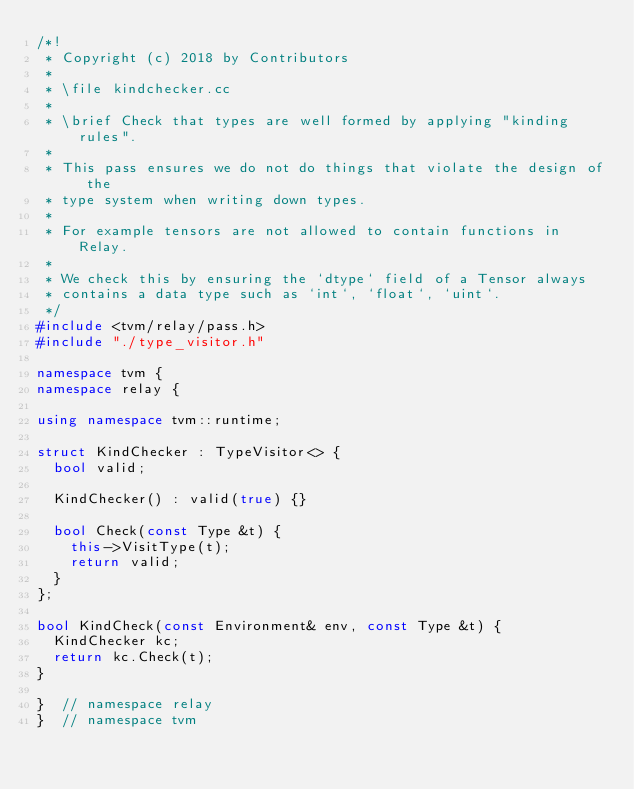Convert code to text. <code><loc_0><loc_0><loc_500><loc_500><_C++_>/*!
 * Copyright (c) 2018 by Contributors
 *
 * \file kindchecker.cc
 *
 * \brief Check that types are well formed by applying "kinding rules".
 *
 * This pass ensures we do not do things that violate the design of the
 * type system when writing down types.
 *
 * For example tensors are not allowed to contain functions in Relay.
 *
 * We check this by ensuring the `dtype` field of a Tensor always
 * contains a data type such as `int`, `float`, `uint`.
 */
#include <tvm/relay/pass.h>
#include "./type_visitor.h"

namespace tvm {
namespace relay {

using namespace tvm::runtime;

struct KindChecker : TypeVisitor<> {
  bool valid;

  KindChecker() : valid(true) {}

  bool Check(const Type &t) {
    this->VisitType(t);
    return valid;
  }
};

bool KindCheck(const Environment& env, const Type &t) {
  KindChecker kc;
  return kc.Check(t);
}

}  // namespace relay
}  // namespace tvm
</code> 